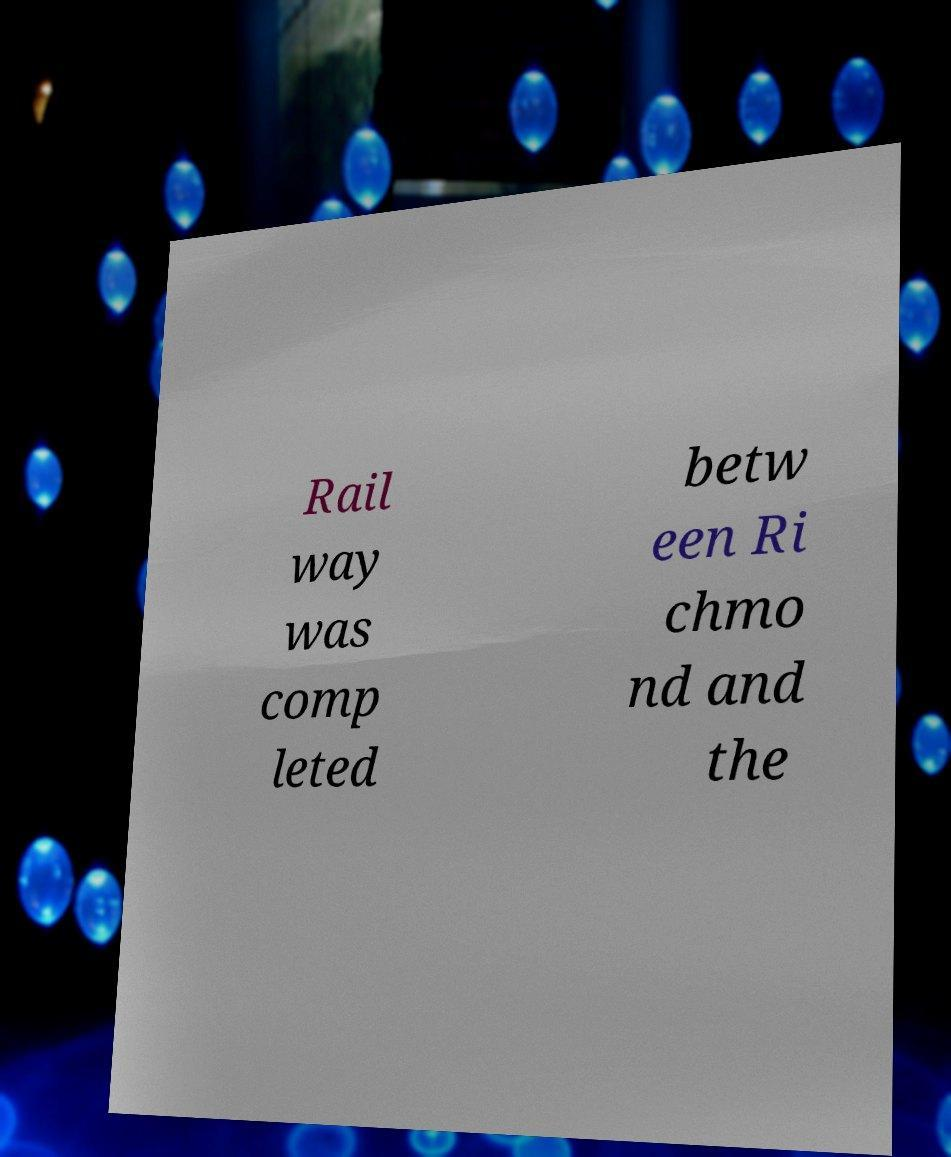Please identify and transcribe the text found in this image. Rail way was comp leted betw een Ri chmo nd and the 